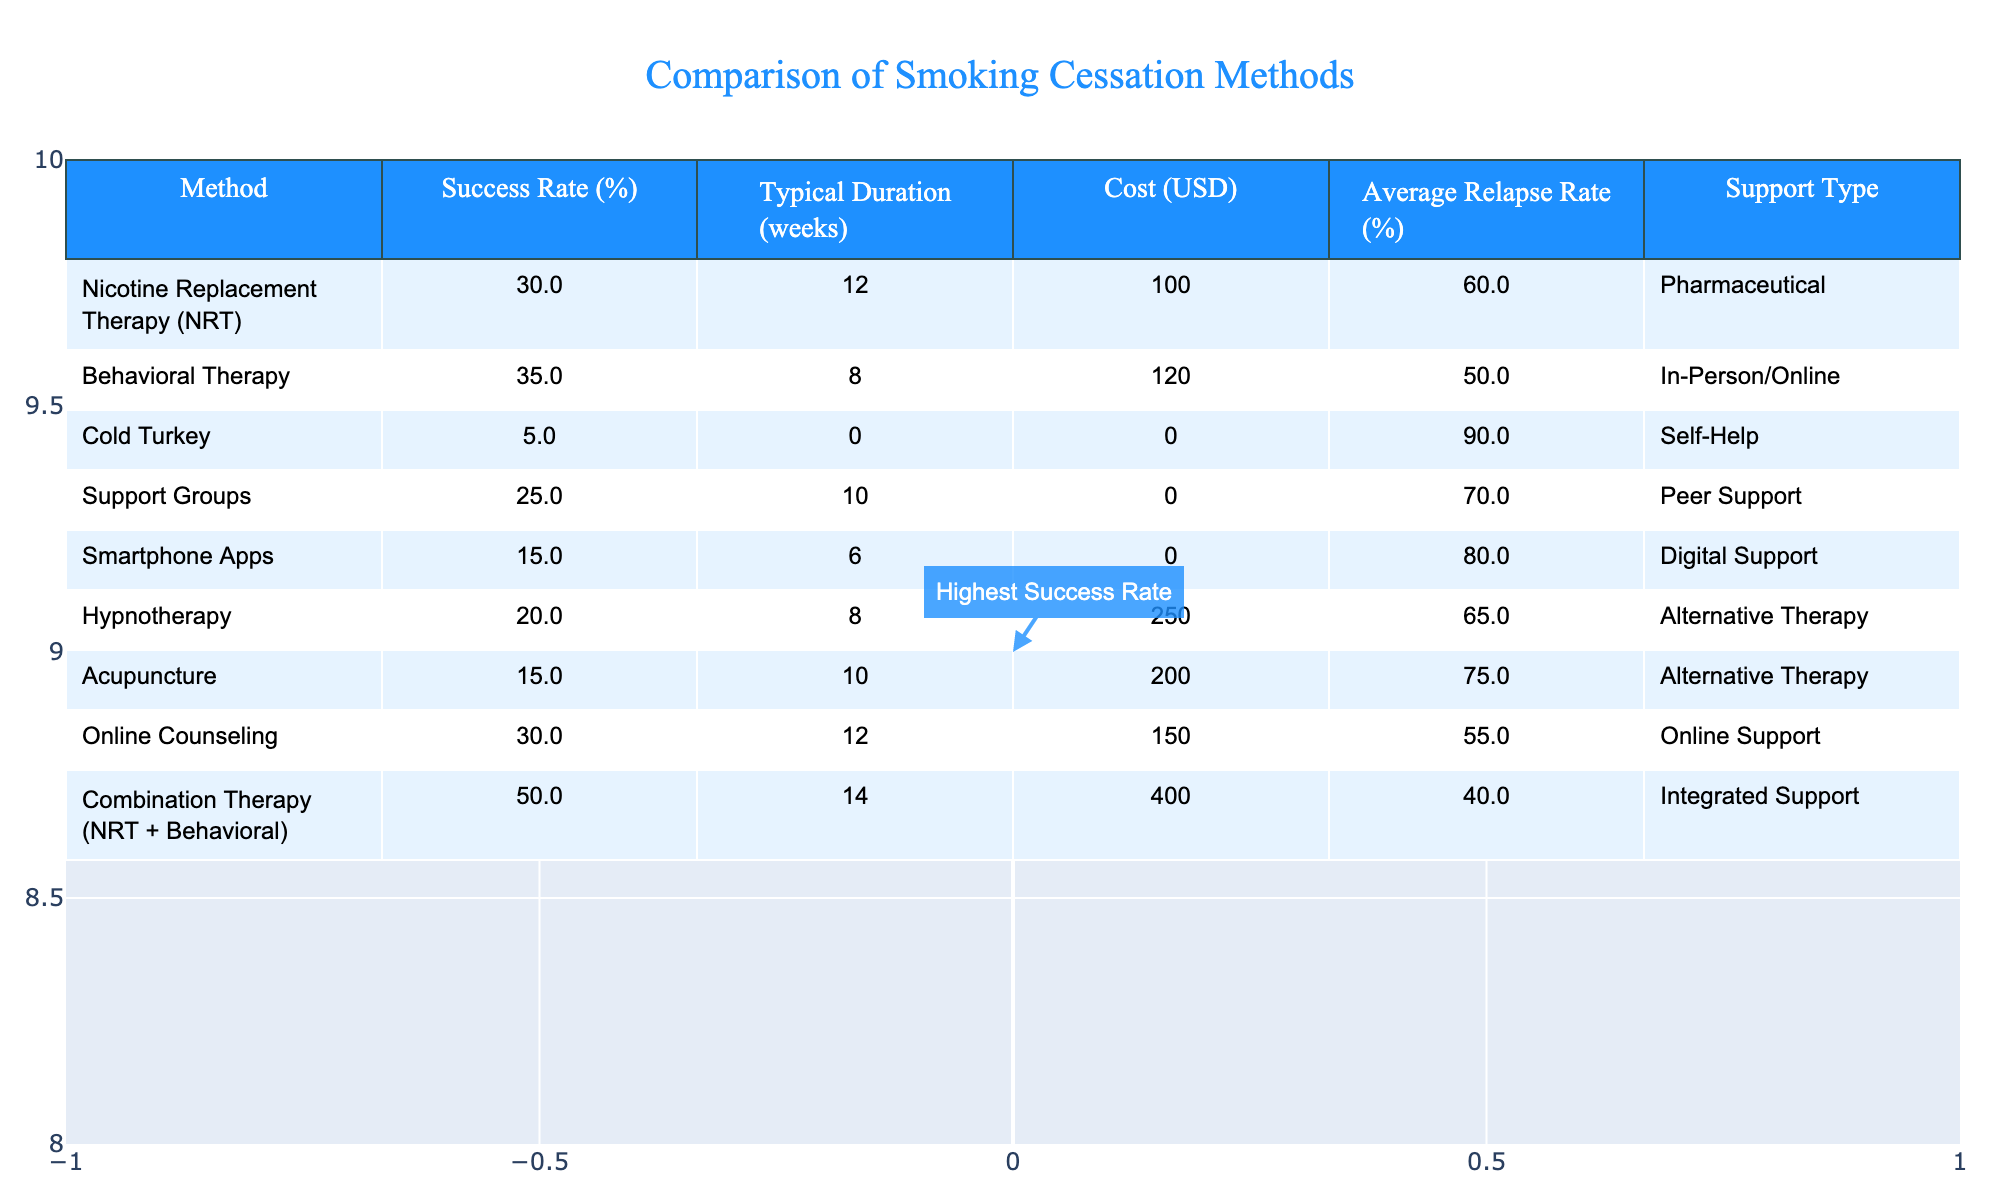What is the success rate of Combination Therapy? The success rate for Combination Therapy is listed in the table under the "Success Rate (%)" column. It states that the success rate is 50%.
Answer: 50% What is the typical duration of Behavioral Therapy? The typical duration for Behavioral Therapy is shown in the "Typical Duration (weeks)" column, which indicates it lasts for 8 weeks.
Answer: 8 weeks Which method has the lowest success rate? To determine the lowest success rate, we can look for the minimum value in the "Success Rate (%)" column. Cold Turkey has the lowest success rate at 5%.
Answer: 5% How much does Acupuncture cost? The cost of Acupuncture is found in the "Cost (USD)" column, where it is listed as 200 USD.
Answer: 200 What is the average relapse rate across all methods? To find the average relapse rate, we sum the "Average Relapse Rate (%)" values of all methods (60 + 50 + 90 + 70 + 80 + 65 + 75 + 55 + 40) and divide by the number of methods (9), resulting in an average of approximately 66.67%.
Answer: 66.67% Is there a method that provides no support type? By reviewing the "Support Type" column, we see that Cold Turkey and other methods do not offer any support type or have self-help as support type, which counts as minimal support. Therefore, the answer is yes, as Cold Turkey essentially has no structured support.
Answer: Yes What is the difference in success rates between Nicotine Replacement Therapy and Support Groups? The success rate for Nicotine Replacement Therapy is 30%, and for Support Groups, it is 25%. The difference is calculated as 30 - 25 = 5%.
Answer: 5% How many methods have a success rate above 20%? By reviewing the "Success Rate (%)" column, we find that four methods—NRT, Behavioral Therapy, Combination Therapy, and Hypnotherapy—have a success rate greater than 20%.
Answer: 4 Which method has the highest success rate, and what type of support does it offer? Combination Therapy has the highest success rate of 50%, and it offers Integrated Support.
Answer: Integrated Support What is the cost difference between Online Counseling and Behavioral Therapy? The cost for Online Counseling is 150 USD, and for Behavioral Therapy, it is 120 USD. The difference is 150 - 120 = 30 USD.
Answer: 30 Which method is the only one with a 100% free cost? By checking the "Cost (USD)" column, Support Groups and Cold Turkey are the only methods listed with a cost of 0 USD.
Answer: Cold Turkey 